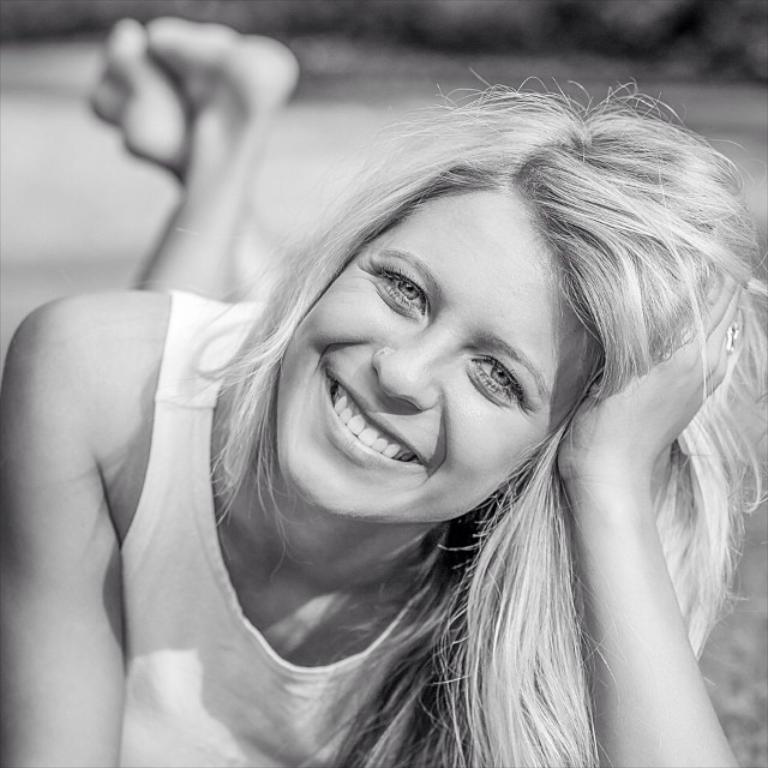Can you describe this image briefly? In this image we can see a lady lying on the ground, the ground, and the background is blurred, also the picture is taken in black and white mode. 